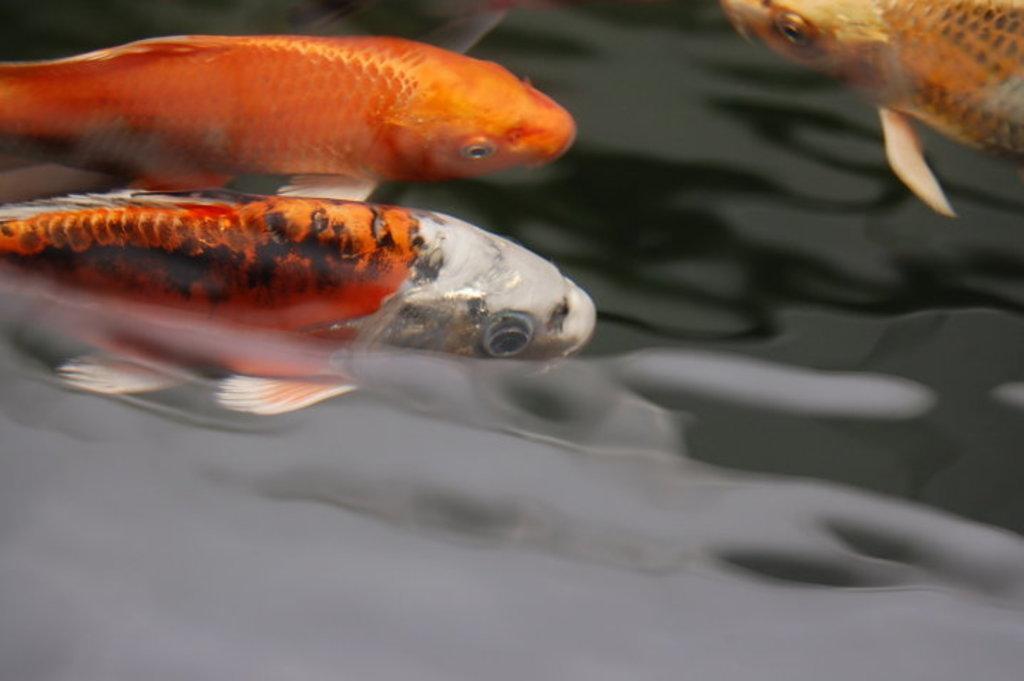Please provide a concise description of this image. There are orange color fishes in the water. 